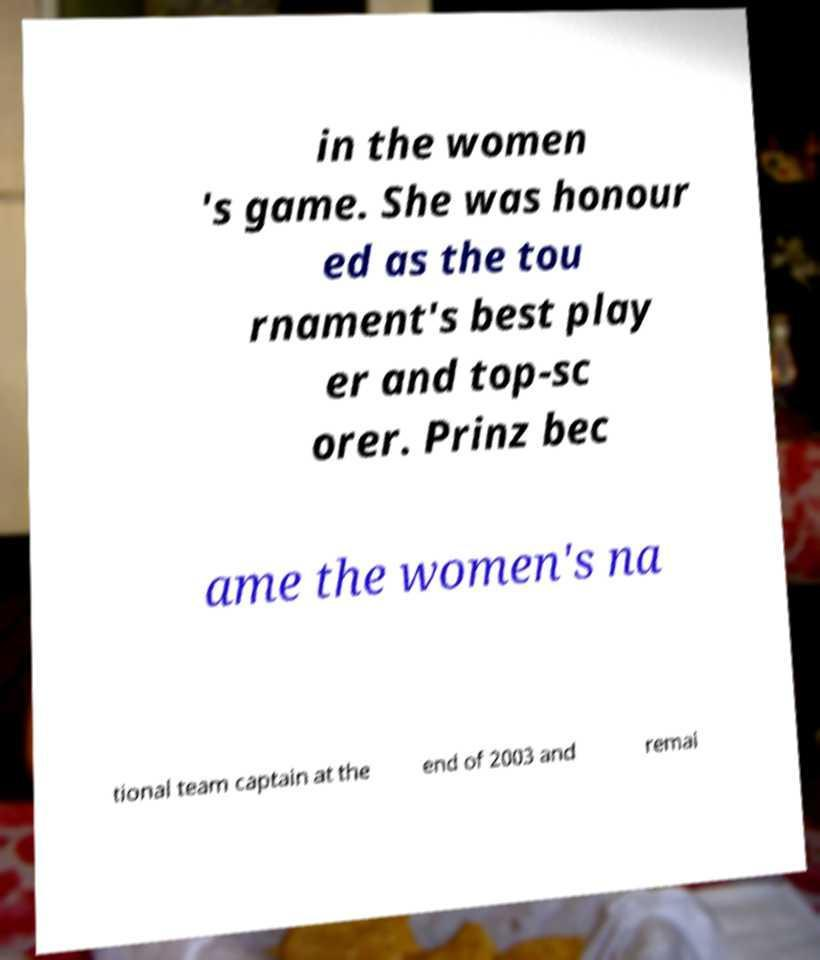Please read and relay the text visible in this image. What does it say? in the women 's game. She was honour ed as the tou rnament's best play er and top-sc orer. Prinz bec ame the women's na tional team captain at the end of 2003 and remai 